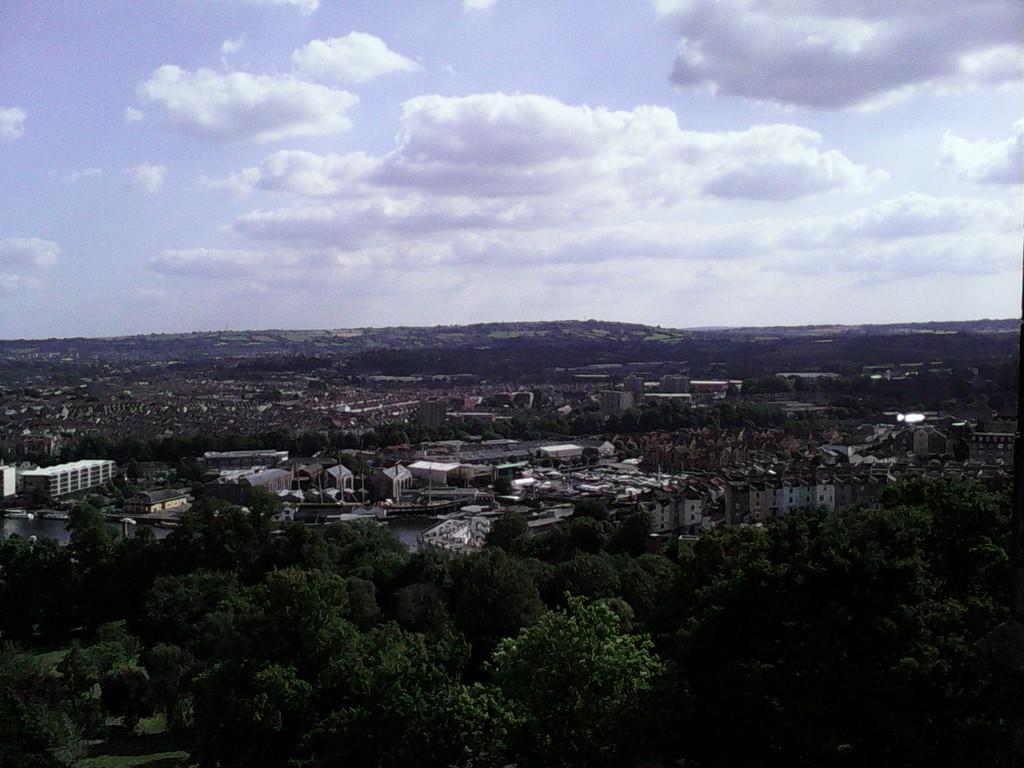What type of natural elements can be seen in the image? There are many trees in the image. What type of man-made structures are visible in the image? There are buildings in the image. What can be seen in the background of the image? The sky is visible in the background of the image. What is the condition of the sky in the image? Clouds are present in the sky. How many sheep can be seen grazing in the image? There are no sheep present in the image. What type of car is parked near the trees in the image? There is no car present in the image; it only features trees, buildings, and the sky. 